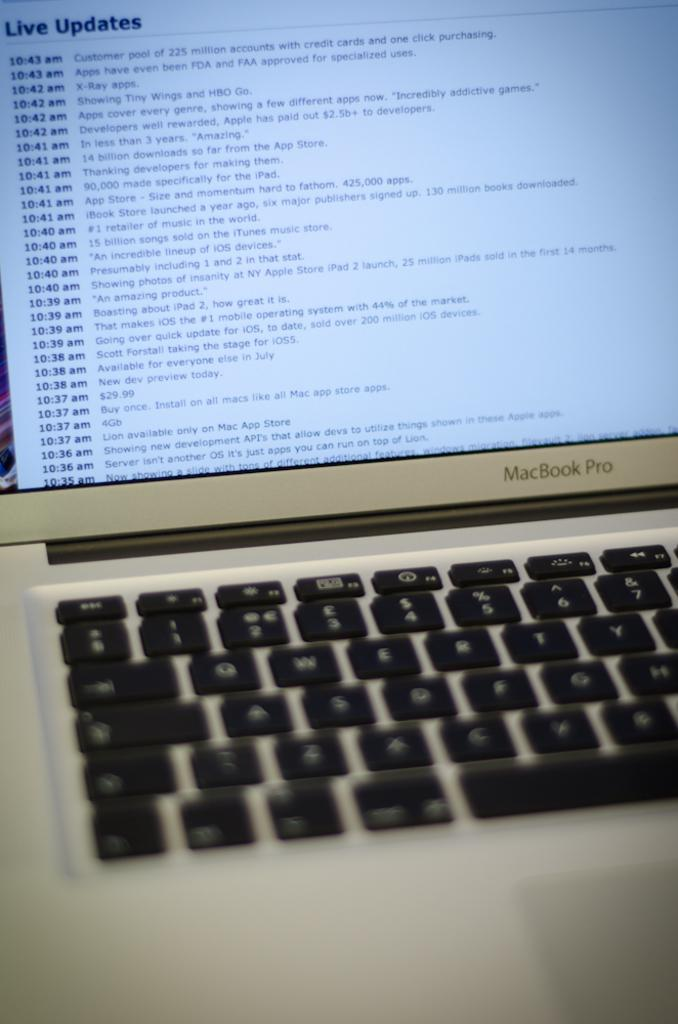Provide a one-sentence caption for the provided image. Macbook pro laptop is getting an live update. 